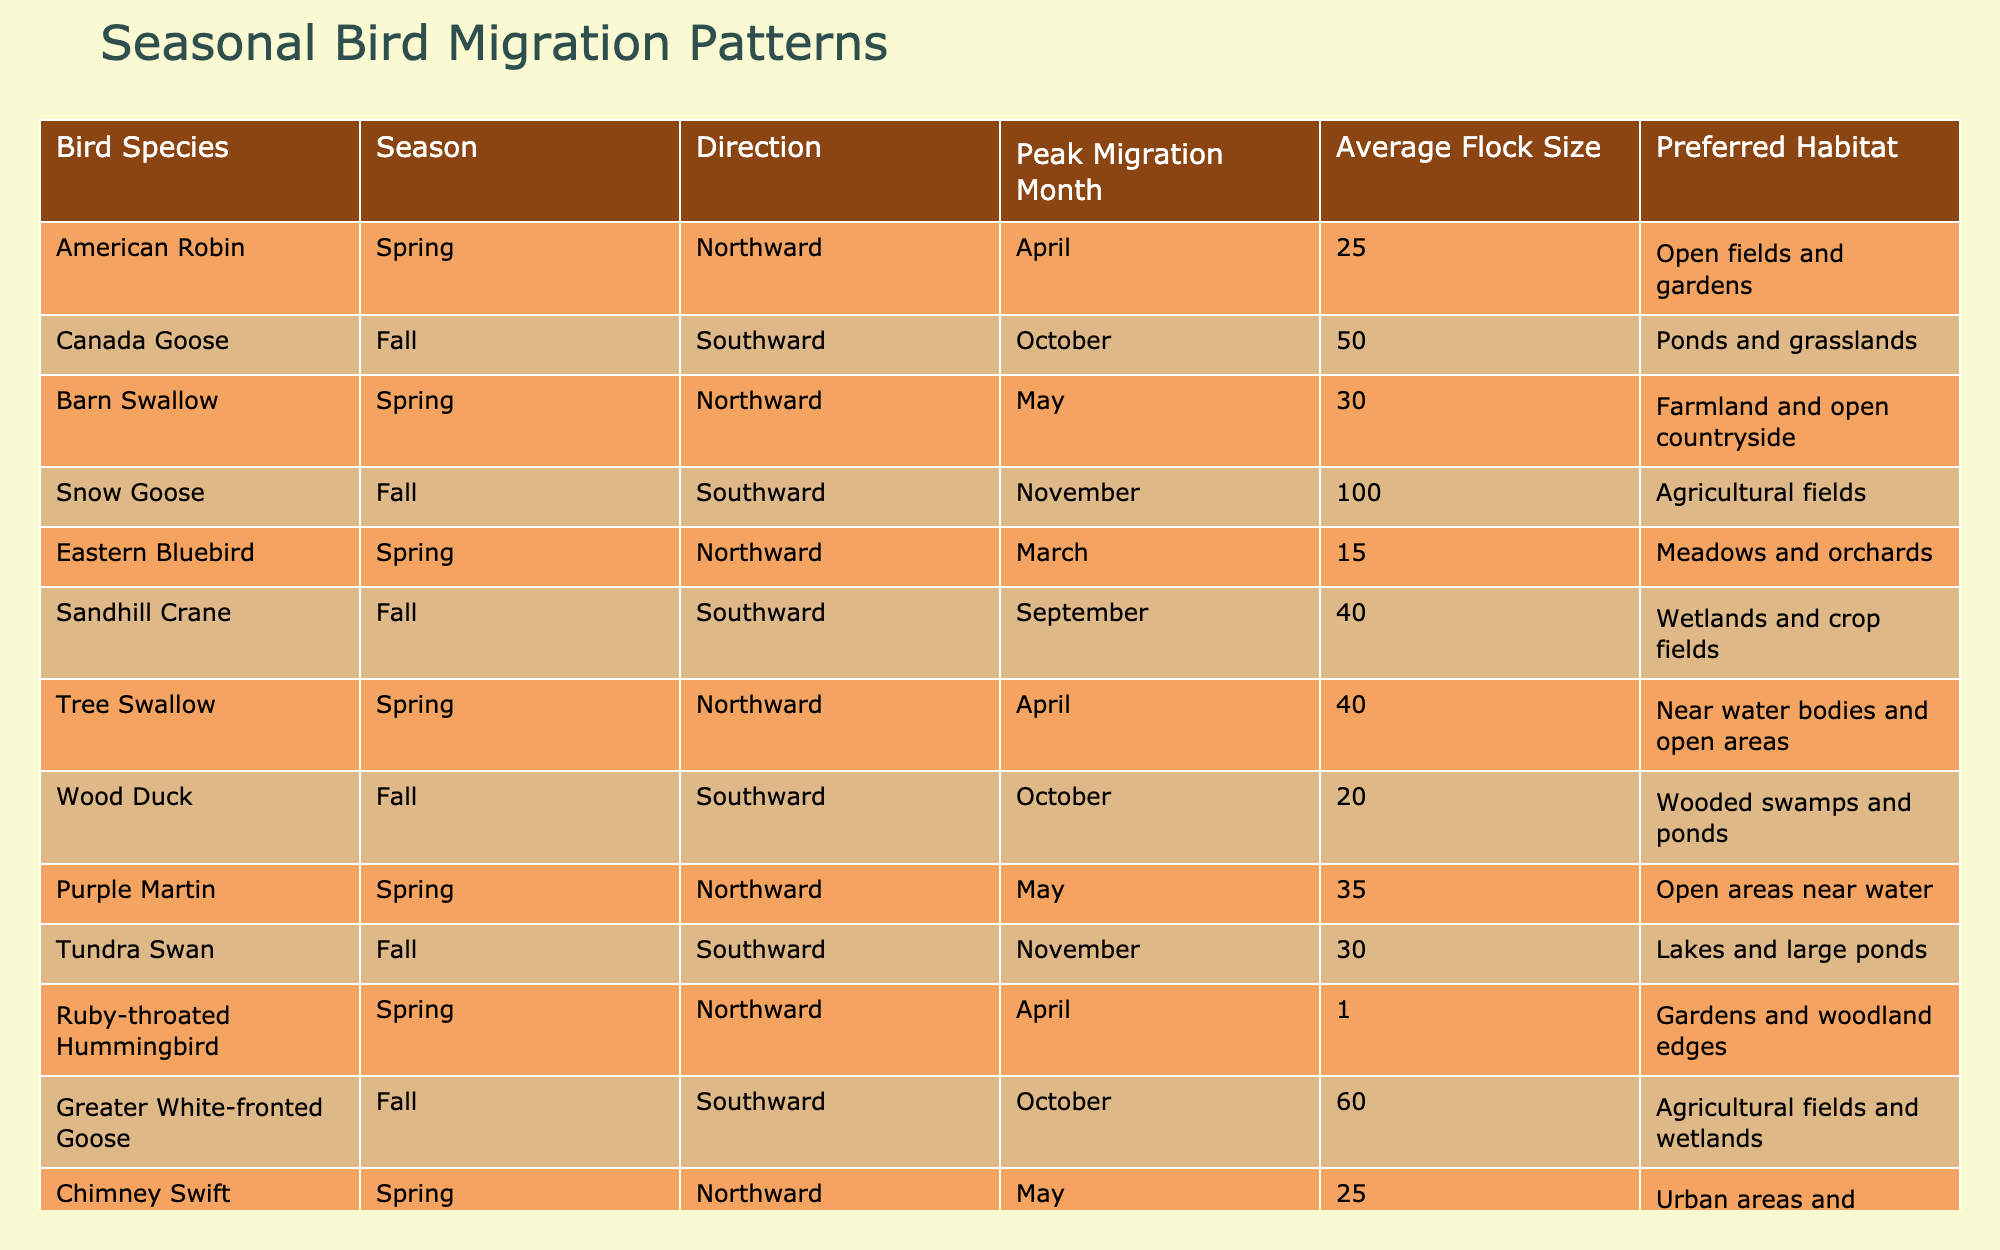What is the peak migration month for the American Robin? The table lists the American Robin under Spring with a peak migration month of April.
Answer: April How many average flock members does the Canada Goose have? The Canada Goose is shown in the table with an average flock size of 50.
Answer: 50 Which bird species prefers open fields and gardens in Spring? The American Robin, as listed in the table, prefers open fields and gardens during Spring.
Answer: American Robin What is the total average flock size of all species migrating Southward in Fall? By examining the Fall migration data, the Southward average flock sizes are 50 (Canada Goose), 100 (Snow Goose), 40 (Sandhill Crane), 20 (Wood Duck), 60 (Greater White-fronted Goose), and 15 (Common Nighthawk). Adding these gives: 50 + 100 + 40 + 20 + 60 + 15 = 285.
Answer: 285 Does the Barn Swallow migrate during Fall? The table indicates that the Barn Swallow migrates in Spring, not Fall.
Answer: No What bird species has the highest average flock size in Fall and what is that size? Looking at the table, the Snow Goose has the highest average flock size of 100 during Fall.
Answer: Snow Goose, 100 What is the average flock size of all bird species that migrate Northward in Spring? The Northward average flock sizes in Spring are 25 (American Robin), 30 (Barn Swallow), 15 (Eastern Bluebird), 40 (Tree Swallow), 35 (Purple Martin), 1 (Ruby-throated Hummingbird), and 10 (Yellow Warbler). The total is 25 + 30 + 15 + 40 + 35 + 1 + 10 = 156, and with 7 species, the average is 156 / 7 = 22.29, which can be rounded to 22.
Answer: Approximately 22 What direction do the Tundra Swans migrate? The table shows that Tundra Swans migrate Southward in Fall.
Answer: Southward Which species migrate in May during Spring? The table lists Barn Swallow, Tree Swallow, and Chimney Swift as migrating in May in Spring.
Answer: Barn Swallow, Tree Swallow, Chimney Swift Is the Yellow Warbler's preferred habitat shrubbery related? The table provides that Yellow Warbler prefers shrubby areas and gardens, confirming a relation to shrubbery.
Answer: Yes 